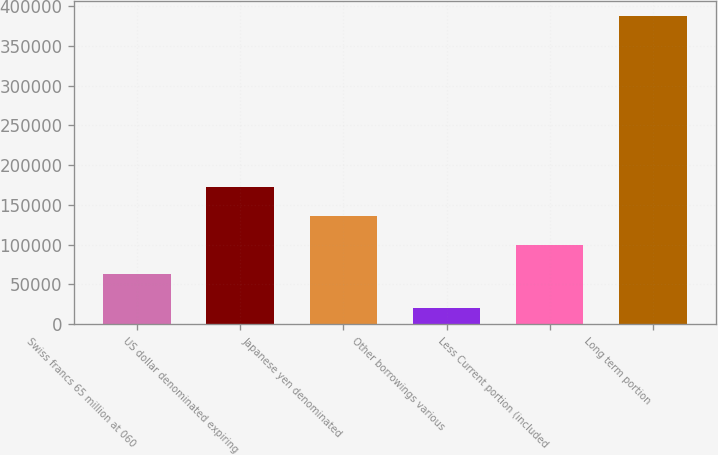Convert chart. <chart><loc_0><loc_0><loc_500><loc_500><bar_chart><fcel>Swiss francs 65 million at 060<fcel>US dollar denominated expiring<fcel>Japanese yen denominated<fcel>Other borrowings various<fcel>Less Current portion (included<fcel>Long term portion<nl><fcel>62844<fcel>172716<fcel>136092<fcel>20911<fcel>99468<fcel>387151<nl></chart> 